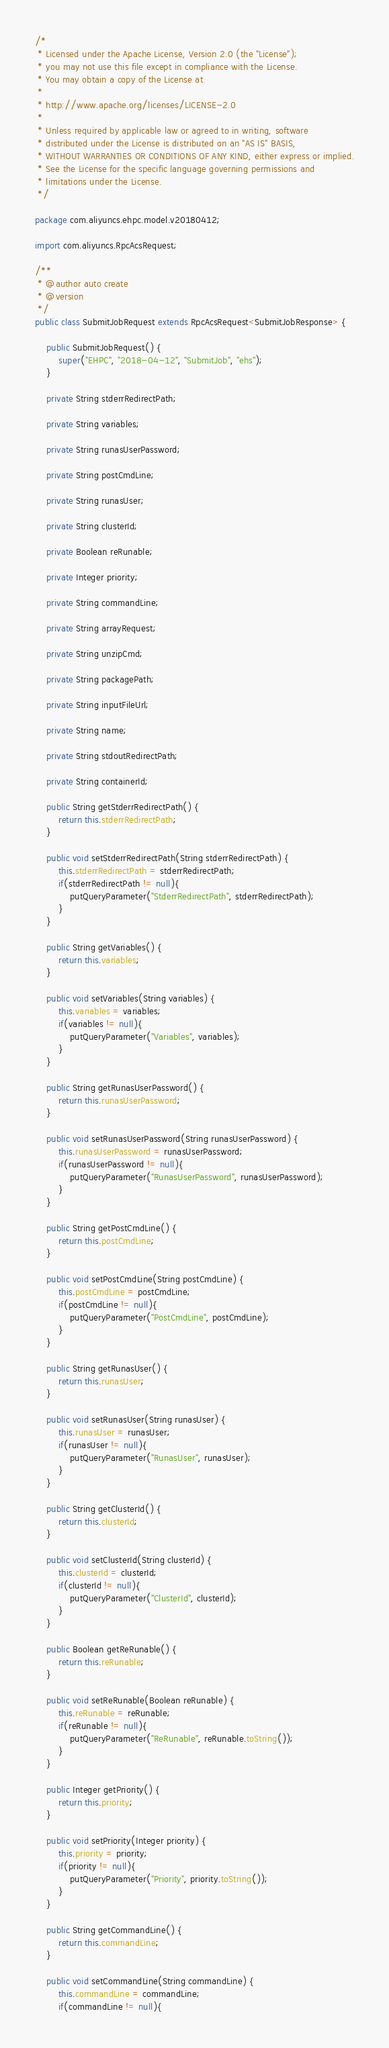Convert code to text. <code><loc_0><loc_0><loc_500><loc_500><_Java_>/*
 * Licensed under the Apache License, Version 2.0 (the "License");
 * you may not use this file except in compliance with the License.
 * You may obtain a copy of the License at
 *
 * http://www.apache.org/licenses/LICENSE-2.0
 *
 * Unless required by applicable law or agreed to in writing, software
 * distributed under the License is distributed on an "AS IS" BASIS,
 * WITHOUT WARRANTIES OR CONDITIONS OF ANY KIND, either express or implied.
 * See the License for the specific language governing permissions and
 * limitations under the License.
 */

package com.aliyuncs.ehpc.model.v20180412;

import com.aliyuncs.RpcAcsRequest;

/**
 * @author auto create
 * @version 
 */
public class SubmitJobRequest extends RpcAcsRequest<SubmitJobResponse> {
	
	public SubmitJobRequest() {
		super("EHPC", "2018-04-12", "SubmitJob", "ehs");
	}

	private String stderrRedirectPath;

	private String variables;

	private String runasUserPassword;

	private String postCmdLine;

	private String runasUser;

	private String clusterId;

	private Boolean reRunable;

	private Integer priority;

	private String commandLine;

	private String arrayRequest;

	private String unzipCmd;

	private String packagePath;

	private String inputFileUrl;

	private String name;

	private String stdoutRedirectPath;

	private String containerId;

	public String getStderrRedirectPath() {
		return this.stderrRedirectPath;
	}

	public void setStderrRedirectPath(String stderrRedirectPath) {
		this.stderrRedirectPath = stderrRedirectPath;
		if(stderrRedirectPath != null){
			putQueryParameter("StderrRedirectPath", stderrRedirectPath);
		}
	}

	public String getVariables() {
		return this.variables;
	}

	public void setVariables(String variables) {
		this.variables = variables;
		if(variables != null){
			putQueryParameter("Variables", variables);
		}
	}

	public String getRunasUserPassword() {
		return this.runasUserPassword;
	}

	public void setRunasUserPassword(String runasUserPassword) {
		this.runasUserPassword = runasUserPassword;
		if(runasUserPassword != null){
			putQueryParameter("RunasUserPassword", runasUserPassword);
		}
	}

	public String getPostCmdLine() {
		return this.postCmdLine;
	}

	public void setPostCmdLine(String postCmdLine) {
		this.postCmdLine = postCmdLine;
		if(postCmdLine != null){
			putQueryParameter("PostCmdLine", postCmdLine);
		}
	}

	public String getRunasUser() {
		return this.runasUser;
	}

	public void setRunasUser(String runasUser) {
		this.runasUser = runasUser;
		if(runasUser != null){
			putQueryParameter("RunasUser", runasUser);
		}
	}

	public String getClusterId() {
		return this.clusterId;
	}

	public void setClusterId(String clusterId) {
		this.clusterId = clusterId;
		if(clusterId != null){
			putQueryParameter("ClusterId", clusterId);
		}
	}

	public Boolean getReRunable() {
		return this.reRunable;
	}

	public void setReRunable(Boolean reRunable) {
		this.reRunable = reRunable;
		if(reRunable != null){
			putQueryParameter("ReRunable", reRunable.toString());
		}
	}

	public Integer getPriority() {
		return this.priority;
	}

	public void setPriority(Integer priority) {
		this.priority = priority;
		if(priority != null){
			putQueryParameter("Priority", priority.toString());
		}
	}

	public String getCommandLine() {
		return this.commandLine;
	}

	public void setCommandLine(String commandLine) {
		this.commandLine = commandLine;
		if(commandLine != null){</code> 